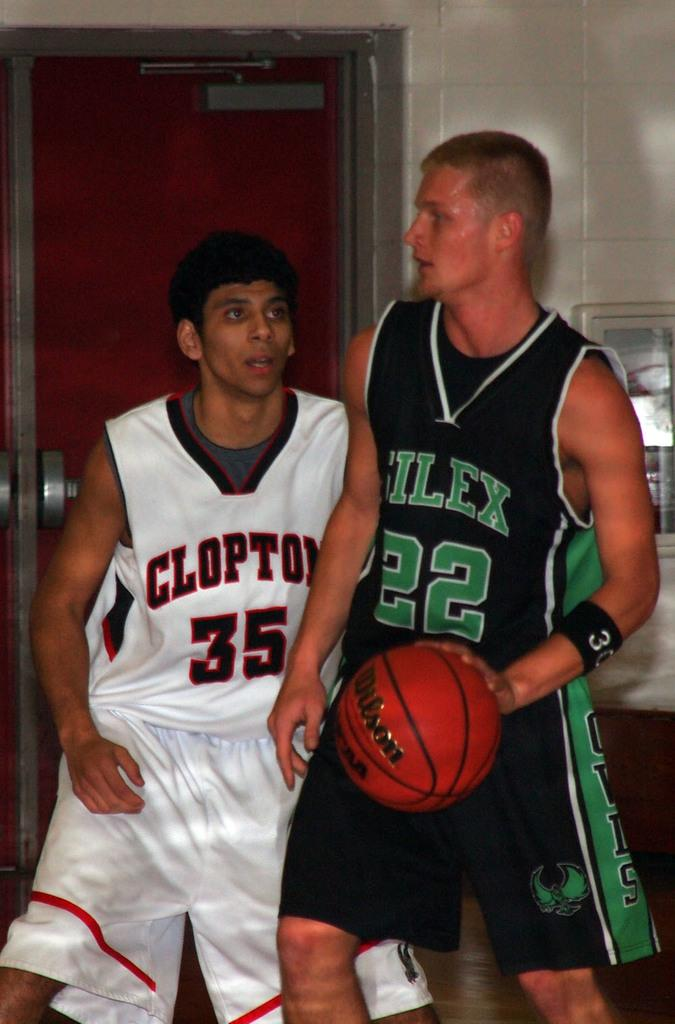<image>
Share a concise interpretation of the image provided. A basketball player wearing the number 35 on his jersey guards another player from the opposing team. 